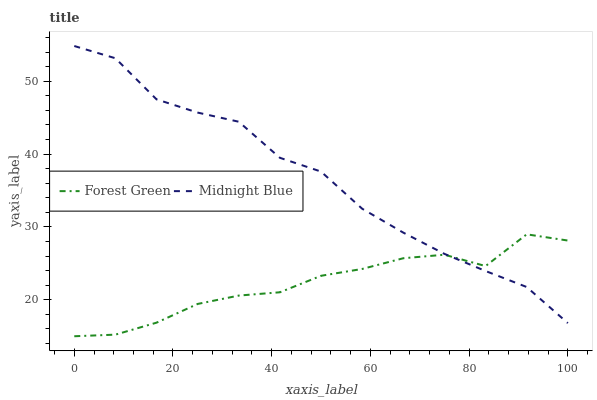Does Forest Green have the minimum area under the curve?
Answer yes or no. Yes. Does Midnight Blue have the maximum area under the curve?
Answer yes or no. Yes. Does Midnight Blue have the minimum area under the curve?
Answer yes or no. No. Is Forest Green the smoothest?
Answer yes or no. Yes. Is Midnight Blue the roughest?
Answer yes or no. Yes. Is Midnight Blue the smoothest?
Answer yes or no. No. Does Forest Green have the lowest value?
Answer yes or no. Yes. Does Midnight Blue have the lowest value?
Answer yes or no. No. Does Midnight Blue have the highest value?
Answer yes or no. Yes. Does Midnight Blue intersect Forest Green?
Answer yes or no. Yes. Is Midnight Blue less than Forest Green?
Answer yes or no. No. Is Midnight Blue greater than Forest Green?
Answer yes or no. No. 